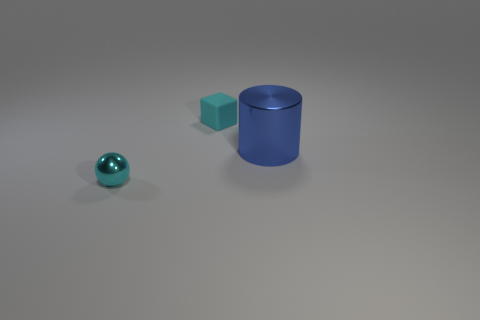Add 2 tiny red cylinders. How many objects exist? 5 Subtract all blocks. How many objects are left? 2 Subtract all large blue cylinders. Subtract all big blue metal cylinders. How many objects are left? 1 Add 2 metal cylinders. How many metal cylinders are left? 3 Add 1 brown shiny things. How many brown shiny things exist? 1 Subtract 0 yellow spheres. How many objects are left? 3 